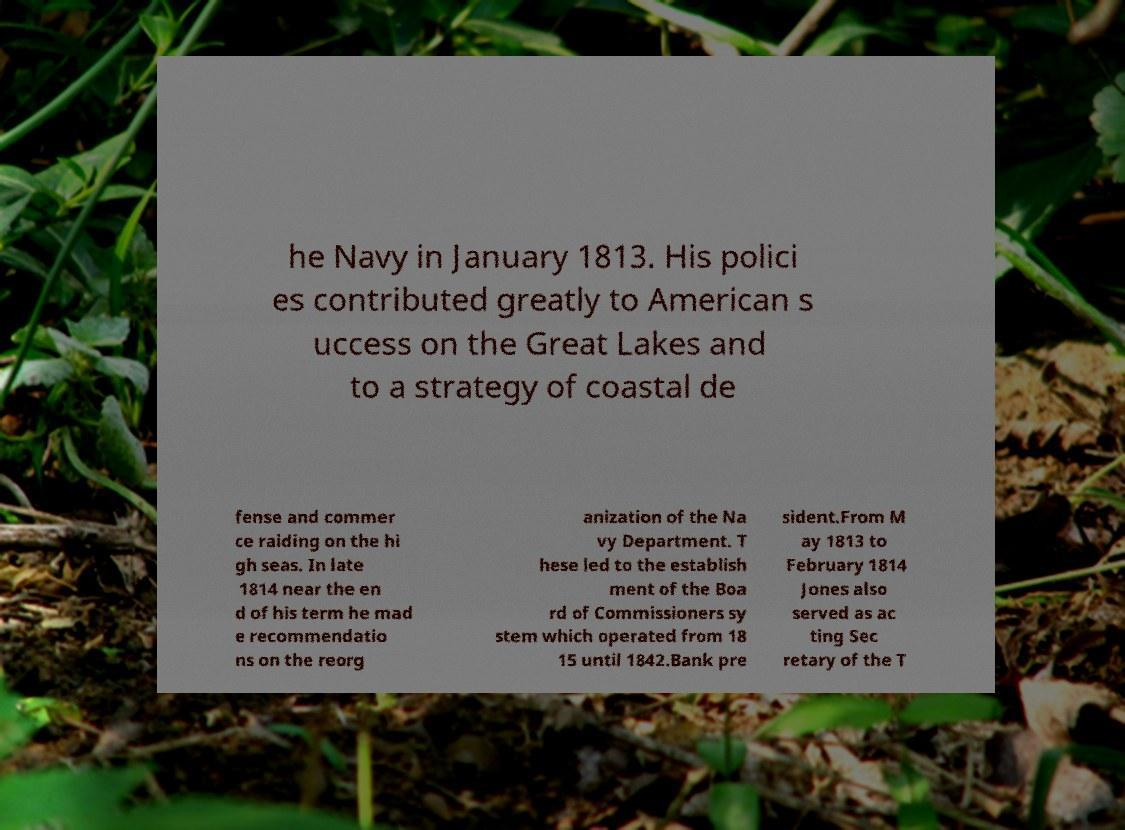What messages or text are displayed in this image? I need them in a readable, typed format. he Navy in January 1813. His polici es contributed greatly to American s uccess on the Great Lakes and to a strategy of coastal de fense and commer ce raiding on the hi gh seas. In late 1814 near the en d of his term he mad e recommendatio ns on the reorg anization of the Na vy Department. T hese led to the establish ment of the Boa rd of Commissioners sy stem which operated from 18 15 until 1842.Bank pre sident.From M ay 1813 to February 1814 Jones also served as ac ting Sec retary of the T 